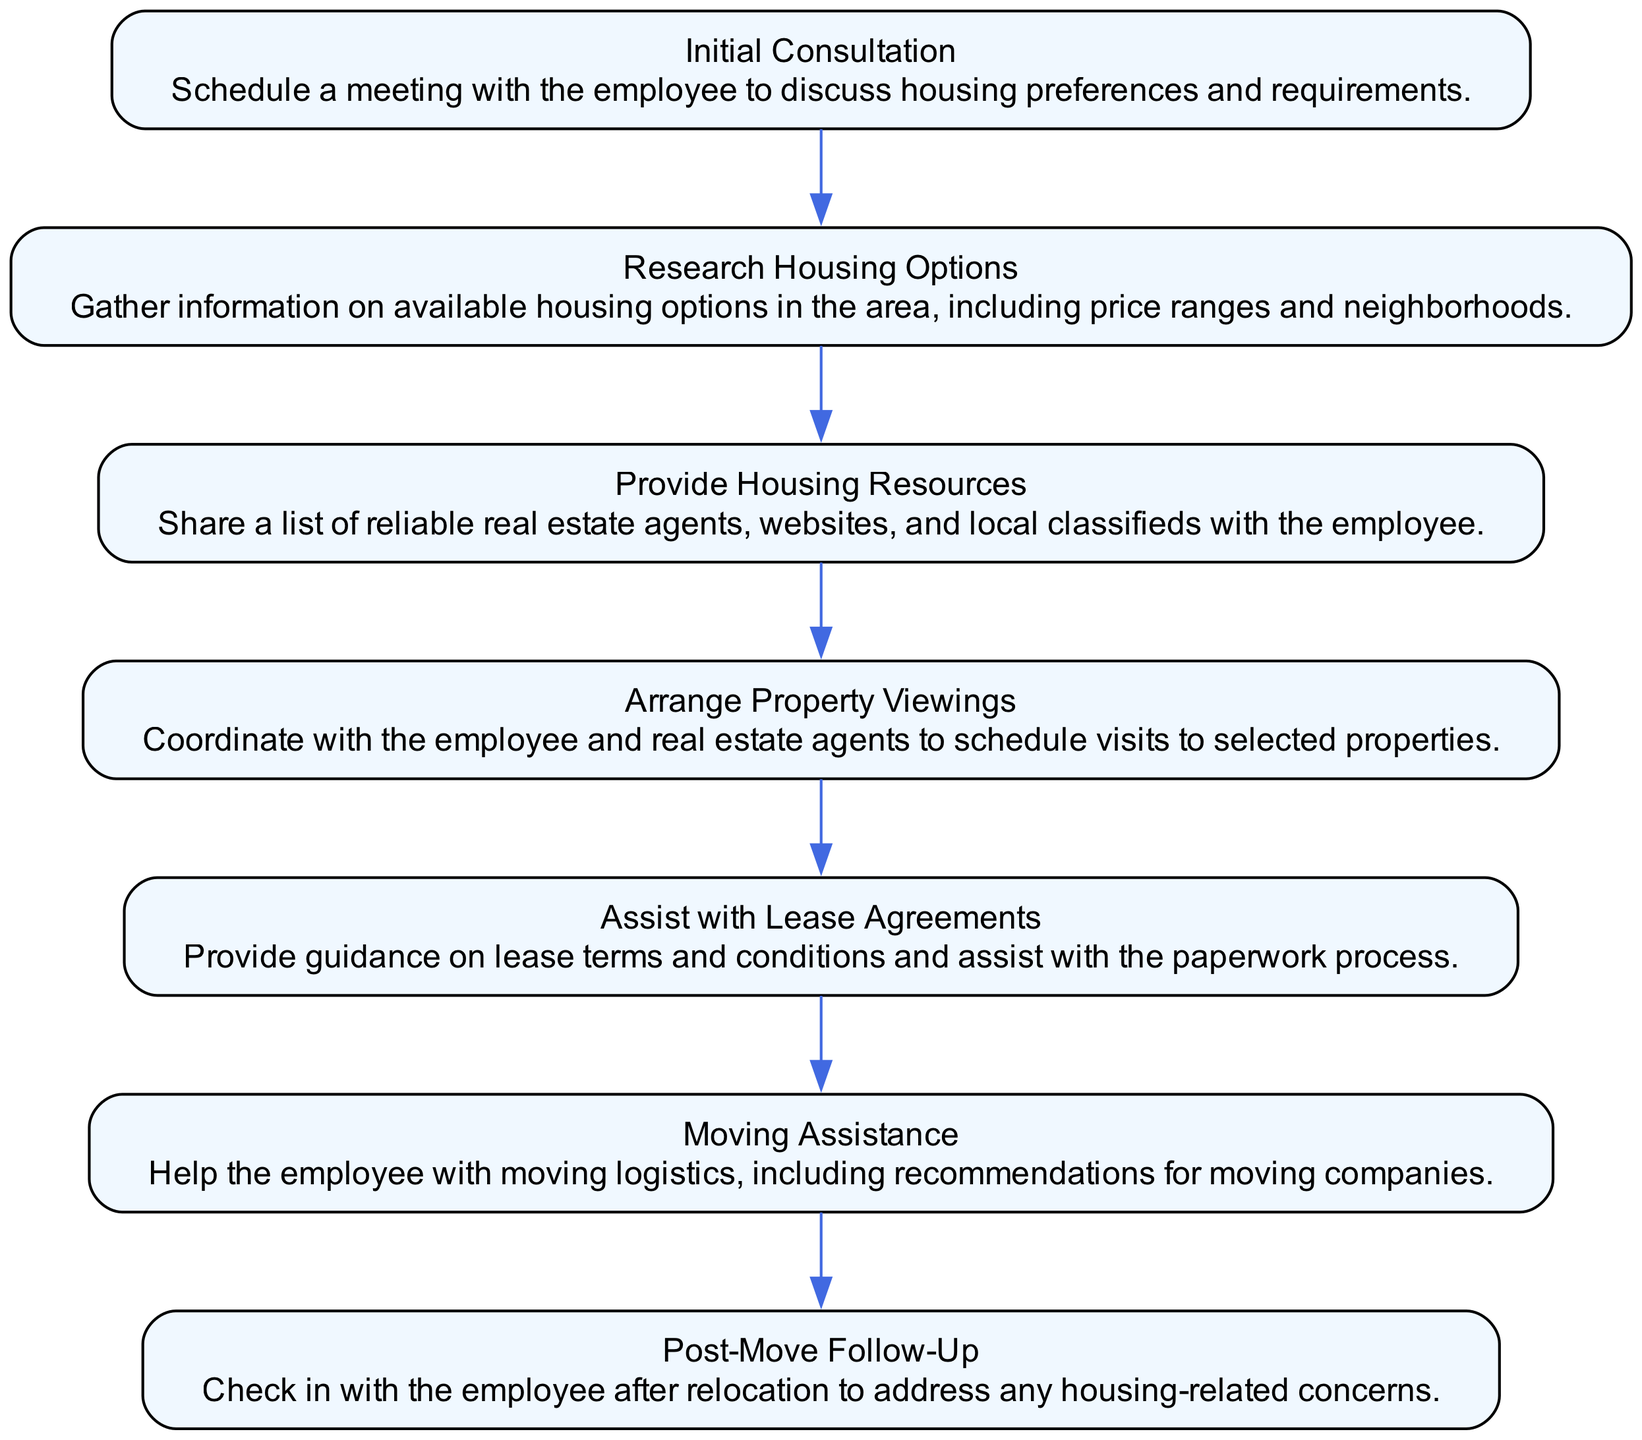What is the first step in the process? The first step is listed as "Initial Consultation," where a meeting is scheduled with the employee to discuss their housing preferences and requirements.
Answer: Initial Consultation How many total steps are there in the diagram? By counting all the nodes representing the steps in the diagram, we find there are seven distinct steps listed.
Answer: 7 What step follows "Research Housing Options"? The diagram shows that "Provide Housing Resources" directly follows "Research Housing Options," indicating it's the next logical step in the process.
Answer: Provide Housing Resources What type of assistance is provided after "Assist with Lease Agreements"? The next step after "Assist with Lease Agreements" is "Moving Assistance," which indicates that support continues towards the moving process.
Answer: Moving Assistance Which step includes coordinating property viewings? The step titled "Arrange Property Viewings" explicitly mentions coordinating with the employee and real estate agents to schedule visits to selected properties, giving a clear indication of its purpose.
Answer: Arrange Property Viewings What is the last step in the process? The last step indicated in the flow chart is "Post-Move Follow-Up," which involves checking in with the employee after their relocation.
Answer: Post-Move Follow-Up What are the primary resources provided in "Provide Housing Resources"? This step encompasses sharing a list of reliable real estate agents, websites, and local classifieds, implying a focus on equipping the employee with valuable tools for their housing search.
Answer: Real estate agents, websites, and local classifieds Which steps involve direct interaction with the employee? The steps "Initial Consultation," "Arrange Property Viewings," and "Moving Assistance" indicate direct interactions with the employee, as they involve discussions, viewings, and logistics associated with the move.
Answer: Initial Consultation, Arrange Property Viewings, Moving Assistance 